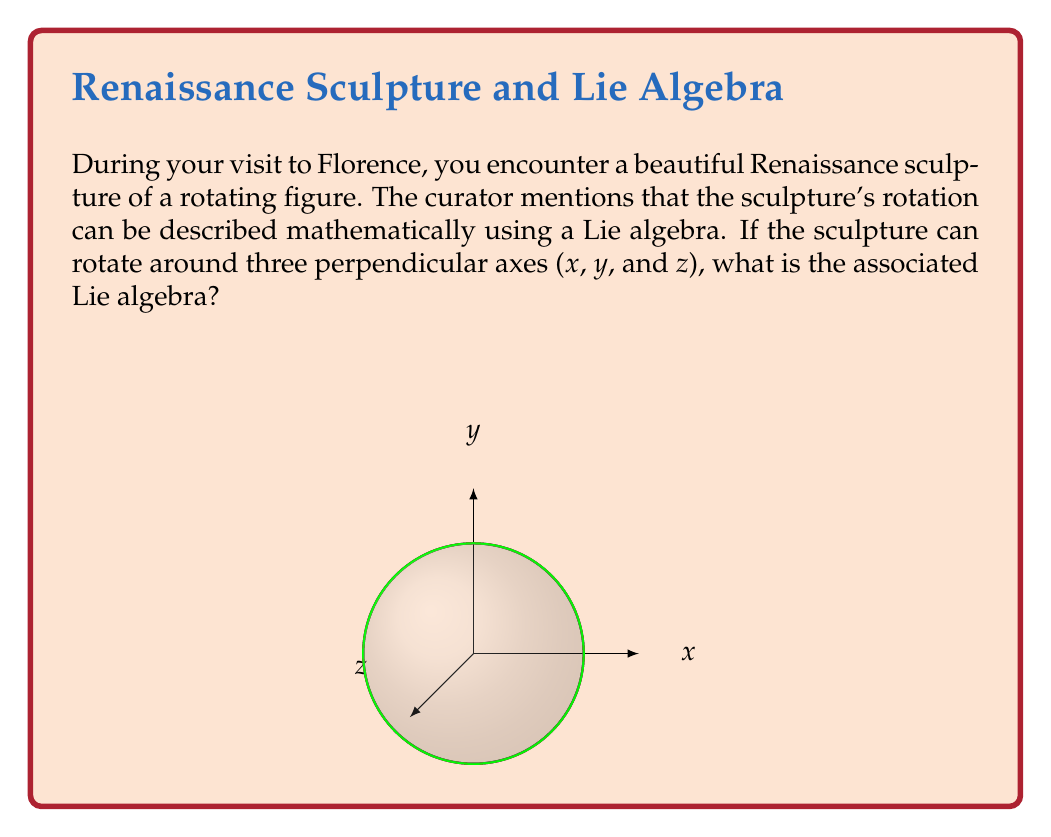Could you help me with this problem? To determine the Lie algebra associated with the rotation group of the sculpture, we follow these steps:

1) The rotation group in three dimensions is known as SO(3) (Special Orthogonal group in 3D).

2) The Lie algebra associated with SO(3) is denoted as so(3).

3) The basis elements of so(3) correspond to infinitesimal rotations around the x, y, and z axes. These are represented by 3x3 skew-symmetric matrices:

   $$J_x = \begin{pmatrix} 0 & 0 & 0 \\ 0 & 0 & -1 \\ 0 & 1 & 0 \end{pmatrix}$$
   $$J_y = \begin{pmatrix} 0 & 0 & 1 \\ 0 & 0 & 0 \\ -1 & 0 & 0 \end{pmatrix}$$
   $$J_z = \begin{pmatrix} 0 & -1 & 0 \\ 1 & 0 & 0 \\ 0 & 0 & 0 \end{pmatrix}$$

4) These matrices satisfy the commutation relations:

   $$[J_x, J_y] = J_z, \quad [J_y, J_z] = J_x, \quad [J_z, J_x] = J_y$$

   where $[A,B] = AB - BA$ is the Lie bracket.

5) The Lie algebra so(3) is therefore a 3-dimensional vector space spanned by $\{J_x, J_y, J_z\}$ with the above commutation relations.

This Lie algebra so(3) completely characterizes the local structure of the rotation group SO(3), which describes all possible rotations of the Renaissance sculpture in three-dimensional space.
Answer: so(3) 